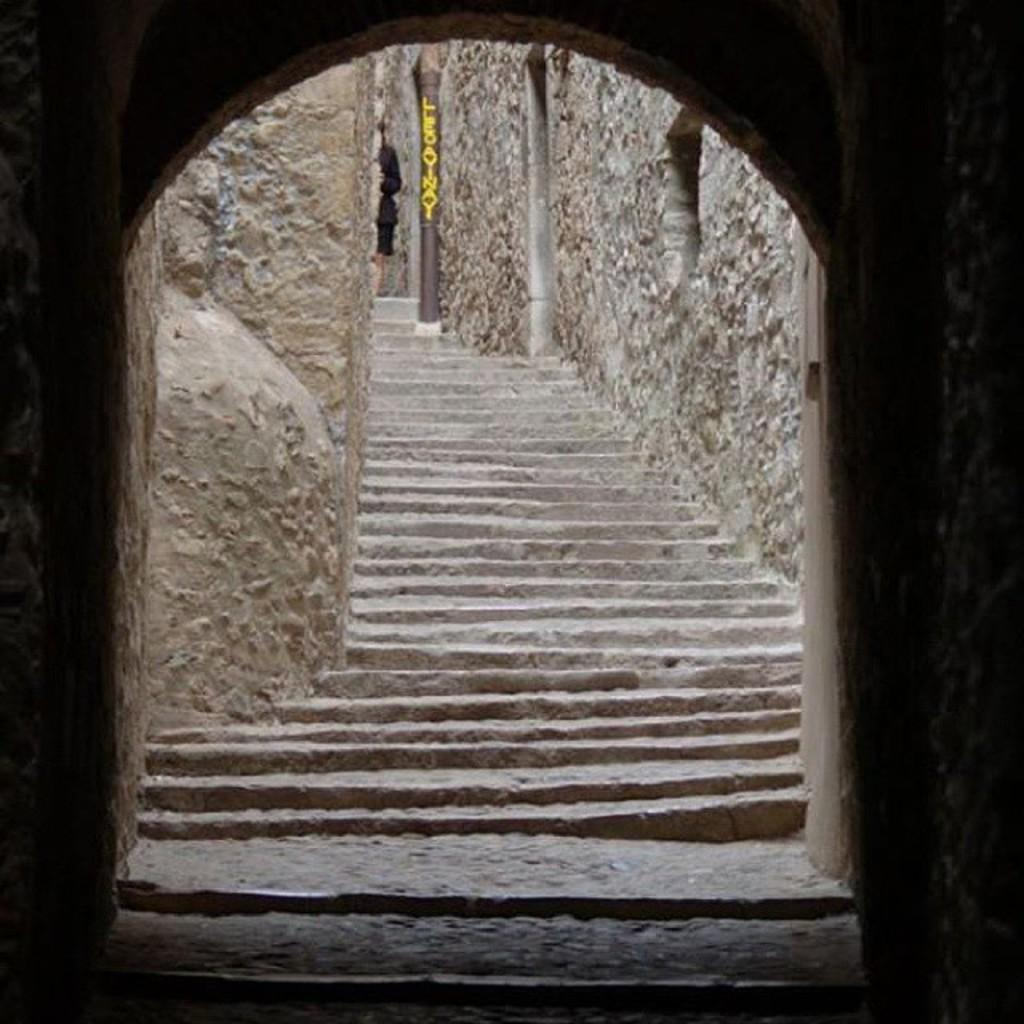What is the main feature of the image? There is a staircase in the image. Where is the staircase located in the image? The staircase is at the center of the image. What type of joke is being told at the top of the staircase in the image? There is no indication of a joke or anyone at the top of the staircase in the image. 